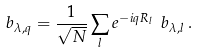Convert formula to latex. <formula><loc_0><loc_0><loc_500><loc_500>b _ { \lambda , { q } } = \frac { 1 } { \sqrt { N } } \sum _ { l } e ^ { - i { q } { R } _ { l } } \ b _ { \lambda , { l } } \, .</formula> 